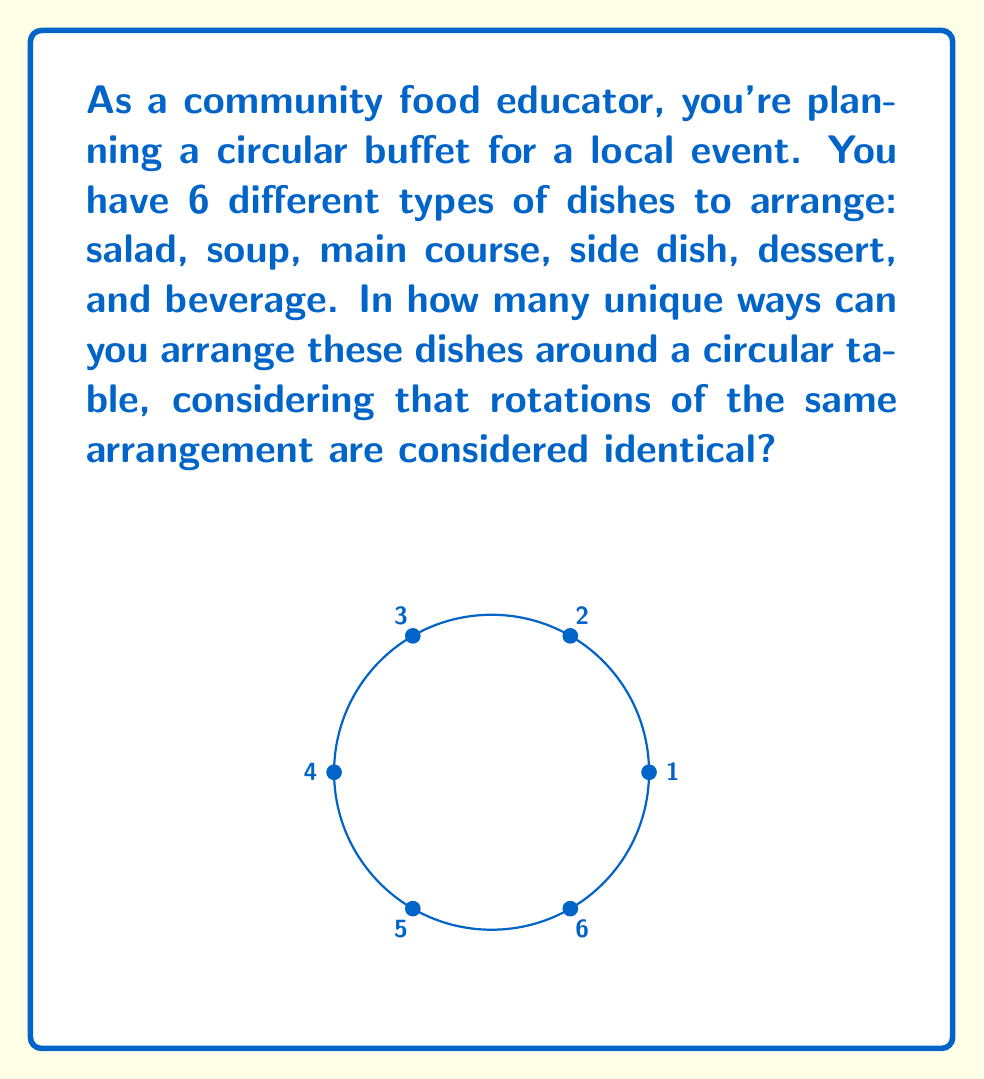Can you solve this math problem? To solve this problem, we need to use the concept of cyclic groups in Group theory. Here's a step-by-step explanation:

1) First, we need to recognize that this is a problem of circular permutations. In a circular arrangement, rotations of the same arrangement are considered identical.

2) For n distinct objects, the number of unique circular permutations is given by $(n-1)!$

3) In this case, we have 6 different types of dishes, so $n = 6$

4) Therefore, the number of unique arrangements is:

   $$(6-1)! = 5!$$

5) Let's calculate 5!:
   $$5! = 5 \times 4 \times 3 \times 2 \times 1 = 120$$

6) This means there are 120 unique ways to arrange the 6 dishes around the circular buffet table.

The reason we use $(n-1)!$ instead of $n!$ is because in a circular arrangement, we can fix the position of one item (say, always start with the salad at the top) and then arrange the rest. This eliminates the redundant rotations of each arrangement.
Answer: 120 